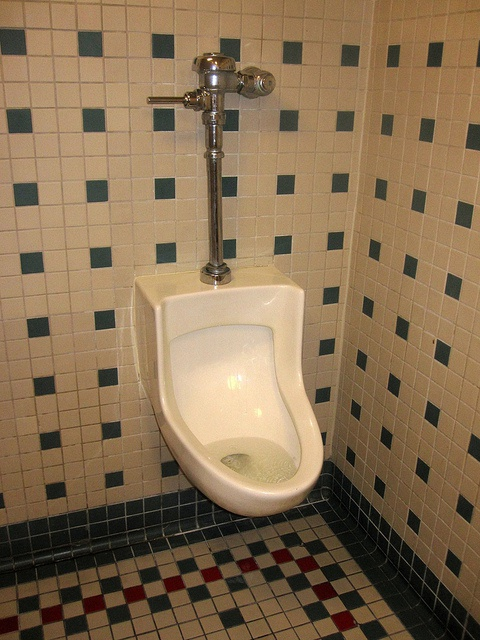Describe the objects in this image and their specific colors. I can see a toilet in gray and tan tones in this image. 